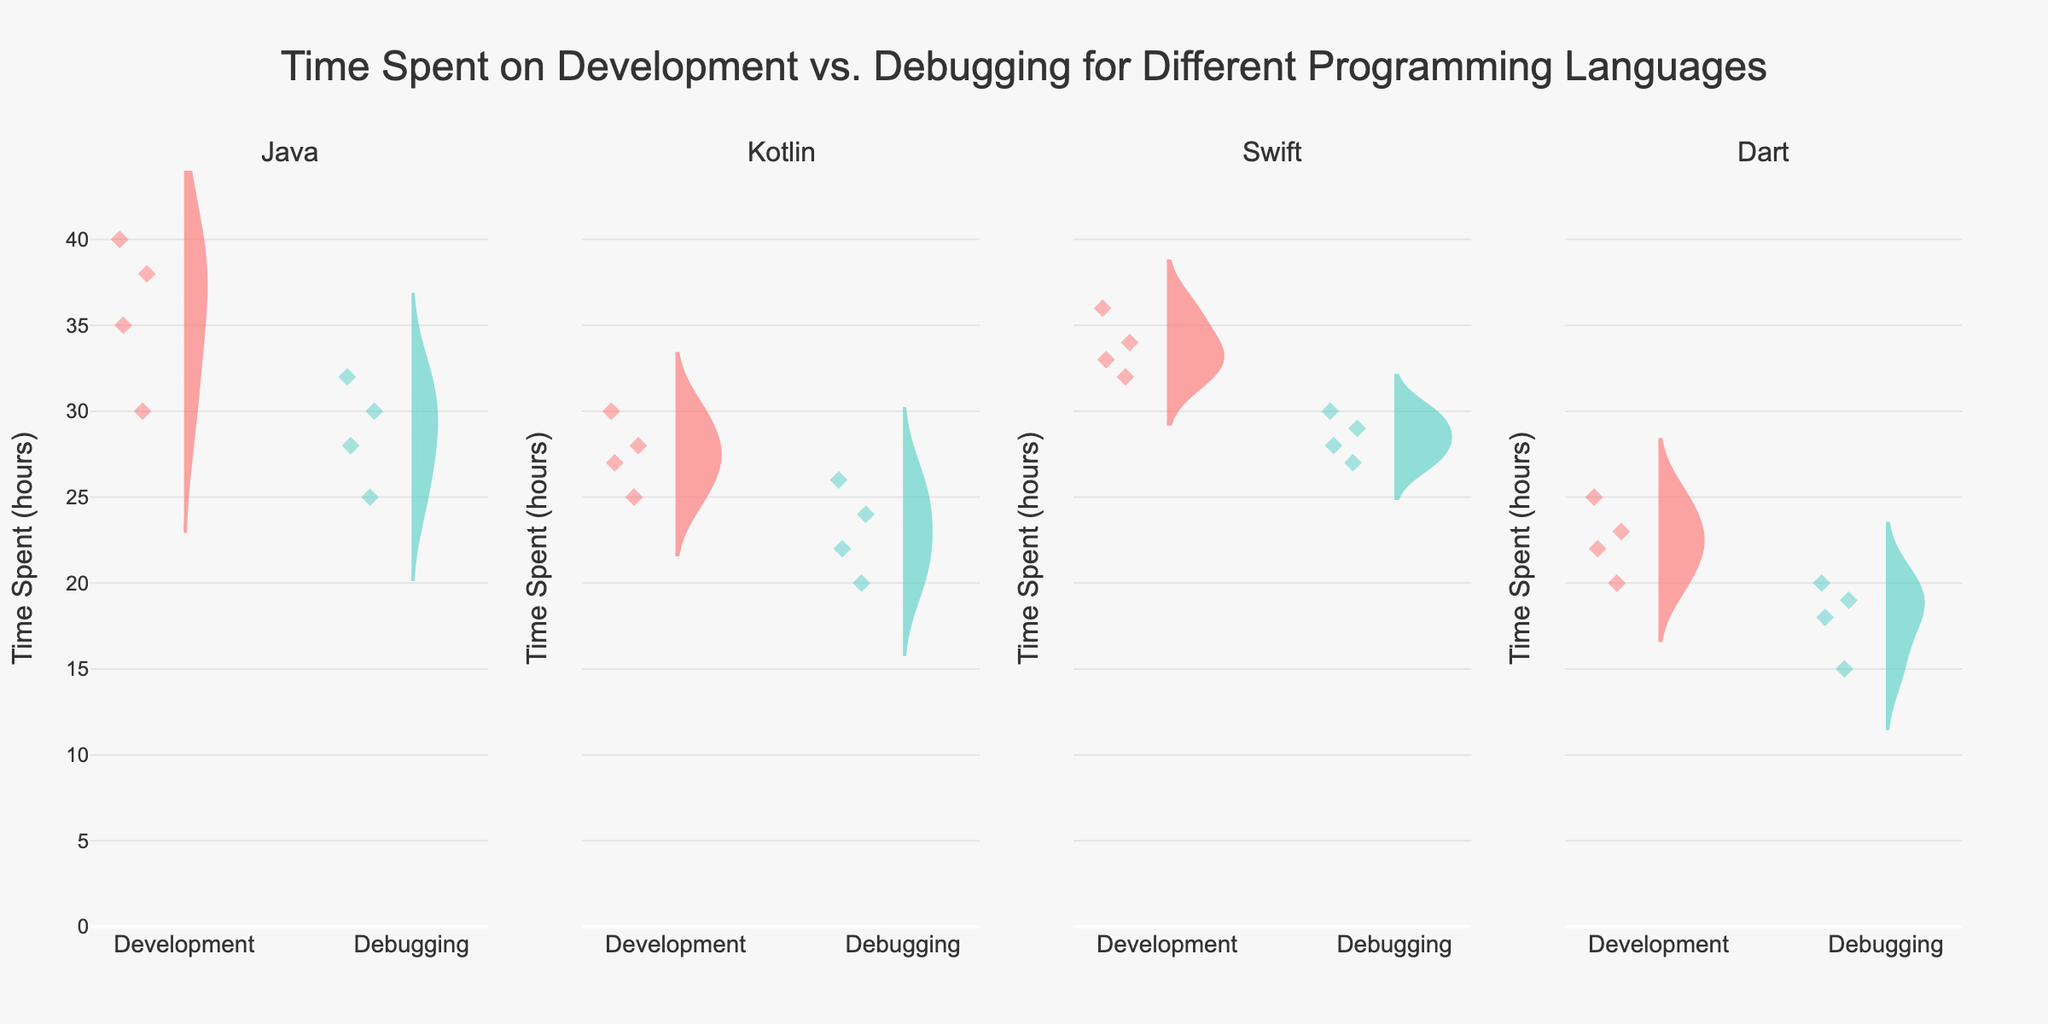What's the title of the figure? The title is generally at the top of the figure. The provided code sets the title as "Time Spent on Development vs. Debugging for Different Programming Languages," which is displayed centrally at the top.
Answer: Time Spent on Development vs. Debugging for Different Programming Languages Which programming language shows the least variability in debugging time? By examining the width of the violin plots for debugging across all programming languages, the one with the narrowest spread indicates the least variability. For Dart, the plot is narrower compared to Java, Kotlin, and Swift, suggesting lower variability.
Answer: Dart How many subplots are there in this figure? The code creates subplots for each programming language. Since there are four unique programming languages (Java, Kotlin, Swift, Dart), there are four subplots.
Answer: Four Which programming language has the highest median time spent on development? The violin plots show a mean line. Use the mean/median line on the plots to find the highest value for development. Swift's development median line appears at around 34, which is higher than Java, Kotlin, and Dart.
Answer: Swift Compare the median debugging time between Swift and Dart. Which is higher? Look at the median lines on the violin plots for debugging activities. Swift has a median debugging time around 28, whereas Dart shows around 18-19. Swift's median is higher.
Answer: Swift What is the median difference in time spent on development and debugging for Kotlin? Find Kotlin's median times for both activities on the violin plots. For development, it's around 27. For debugging, it's approximately 22-23. The difference (27 - 22) is about 4-5 hours.
Answer: 4-5 hours Which activity shows more outliers in the Java subplot, development or debugging? In violin plots, outliers are usually marked as individual points. By counting the points outside the main density area, development in Java seems to show more outliers than debugging.
Answer: Development Which programming language shows the closest median time values for both development and debugging activities? By comparing the median lines in each subplot for both activities, Kotlin shows the closest time values (development around 27, debugging around 22-23).
Answer: Kotlin What's the upper range limit of the y-axis in this figure? According to the code, the y-axis range is calculated as 1.1 times the maximum value in 'TimeSpent' data. The maximum value is 40, hence the range should be approximately 44.
Answer: 44 